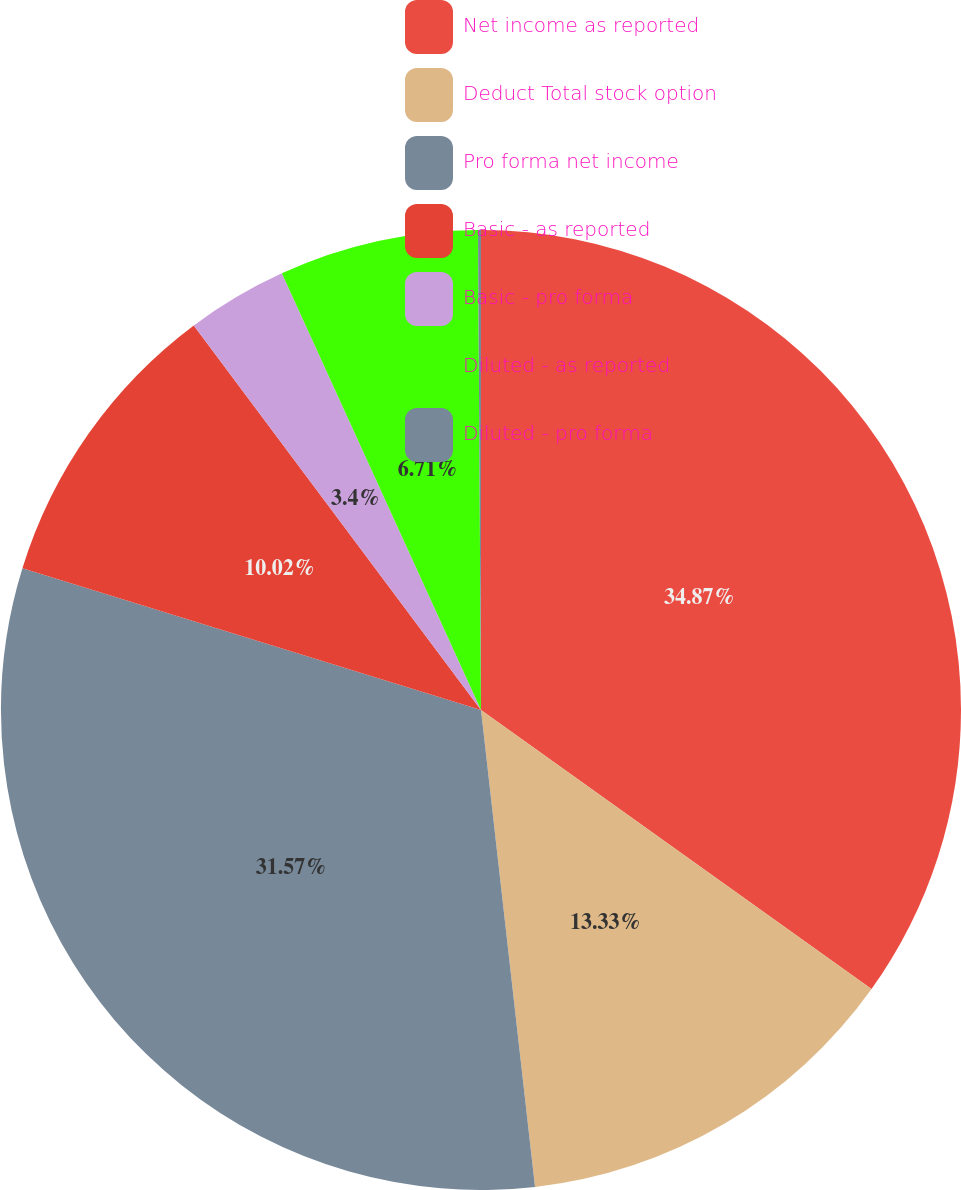<chart> <loc_0><loc_0><loc_500><loc_500><pie_chart><fcel>Net income as reported<fcel>Deduct Total stock option<fcel>Pro forma net income<fcel>Basic - as reported<fcel>Basic - pro forma<fcel>Diluted - as reported<fcel>Diluted - pro forma<nl><fcel>34.88%<fcel>13.33%<fcel>31.57%<fcel>10.02%<fcel>3.4%<fcel>6.71%<fcel>0.1%<nl></chart> 